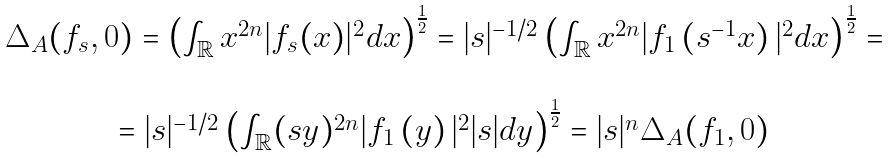Convert formula to latex. <formula><loc_0><loc_0><loc_500><loc_500>\begin{array} { c } \Delta _ { A } ( f _ { s } , 0 ) = \left ( \int _ { \mathbb { R } } x ^ { 2 n } | f _ { s } ( x ) | ^ { 2 } d x \right ) ^ { \frac { 1 } { 2 } } = | s | ^ { - 1 / 2 } \left ( \int _ { \mathbb { R } } x ^ { 2 n } | f _ { 1 } \left ( s ^ { - 1 } x \right ) | ^ { 2 } d x \right ) ^ { \frac { 1 } { 2 } } = \\ \\ = | s | ^ { - 1 / 2 } \left ( \int _ { \mathbb { R } } ( s y ) ^ { 2 n } | f _ { 1 } \left ( y \right ) | ^ { 2 } | s | d y \right ) ^ { \frac { 1 } { 2 } } = | s | ^ { n } \Delta _ { A } ( f _ { 1 } , 0 ) \end{array}</formula> 